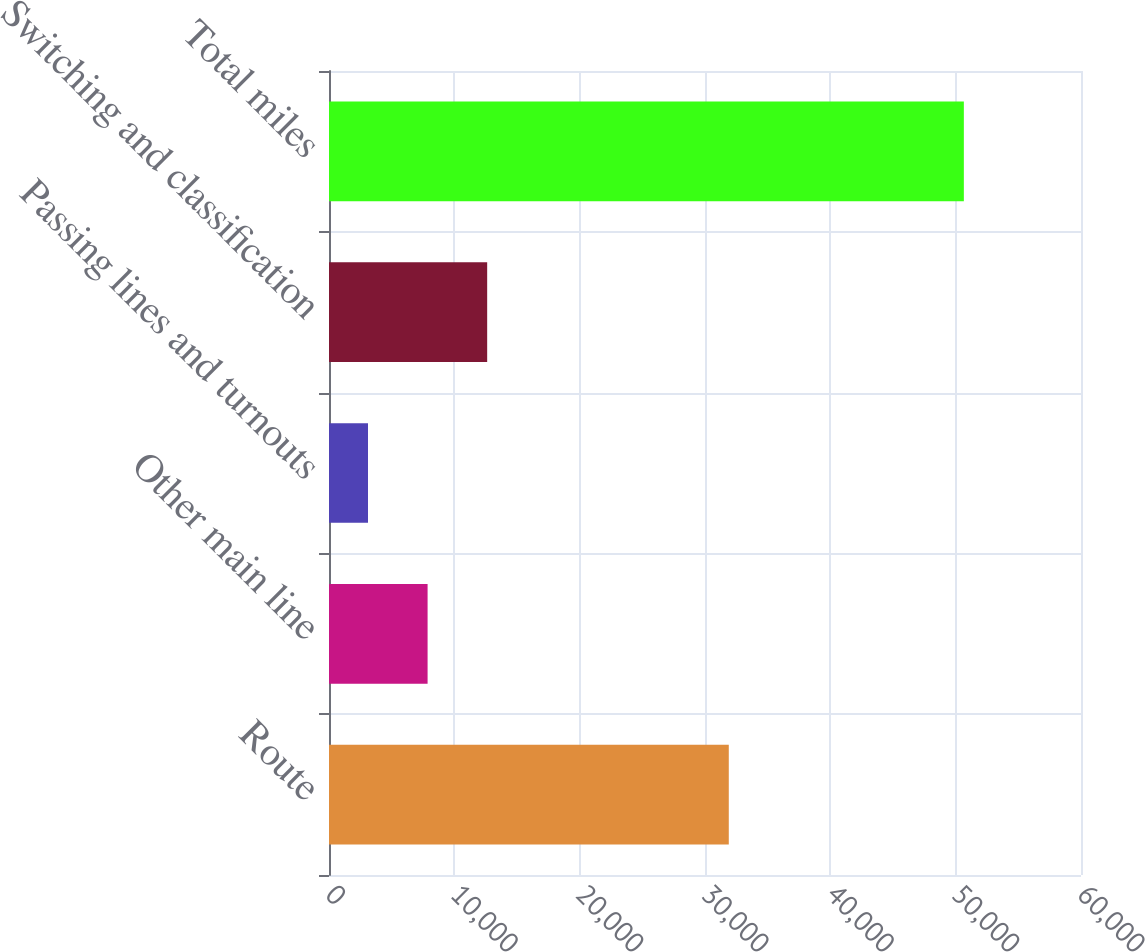Convert chart. <chart><loc_0><loc_0><loc_500><loc_500><bar_chart><fcel>Route<fcel>Other main line<fcel>Passing lines and turnouts<fcel>Switching and classification<fcel>Total miles<nl><fcel>31898<fcel>7866.1<fcel>3112<fcel>12620.2<fcel>50653<nl></chart> 